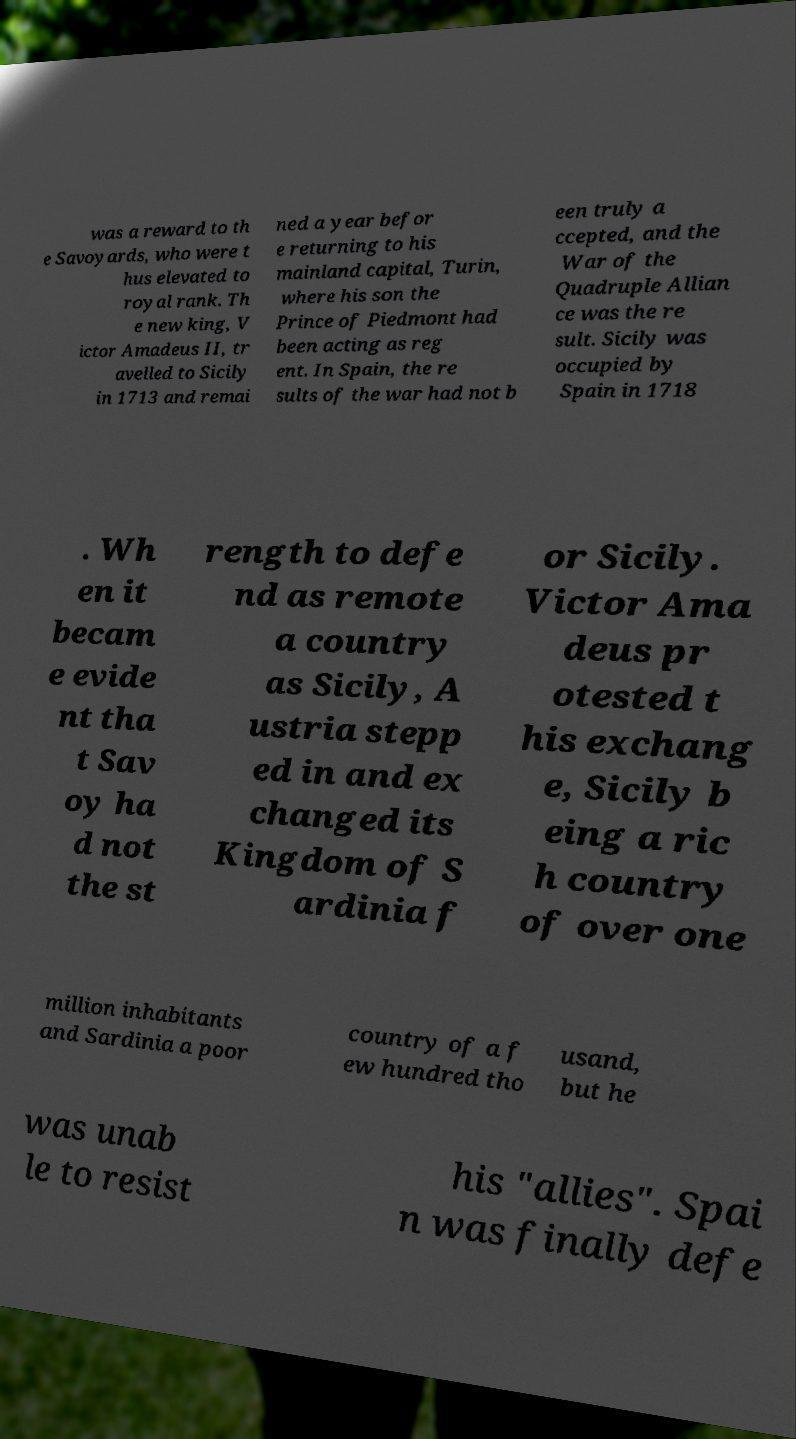Please read and relay the text visible in this image. What does it say? was a reward to th e Savoyards, who were t hus elevated to royal rank. Th e new king, V ictor Amadeus II, tr avelled to Sicily in 1713 and remai ned a year befor e returning to his mainland capital, Turin, where his son the Prince of Piedmont had been acting as reg ent. In Spain, the re sults of the war had not b een truly a ccepted, and the War of the Quadruple Allian ce was the re sult. Sicily was occupied by Spain in 1718 . Wh en it becam e evide nt tha t Sav oy ha d not the st rength to defe nd as remote a country as Sicily, A ustria stepp ed in and ex changed its Kingdom of S ardinia f or Sicily. Victor Ama deus pr otested t his exchang e, Sicily b eing a ric h country of over one million inhabitants and Sardinia a poor country of a f ew hundred tho usand, but he was unab le to resist his "allies". Spai n was finally defe 